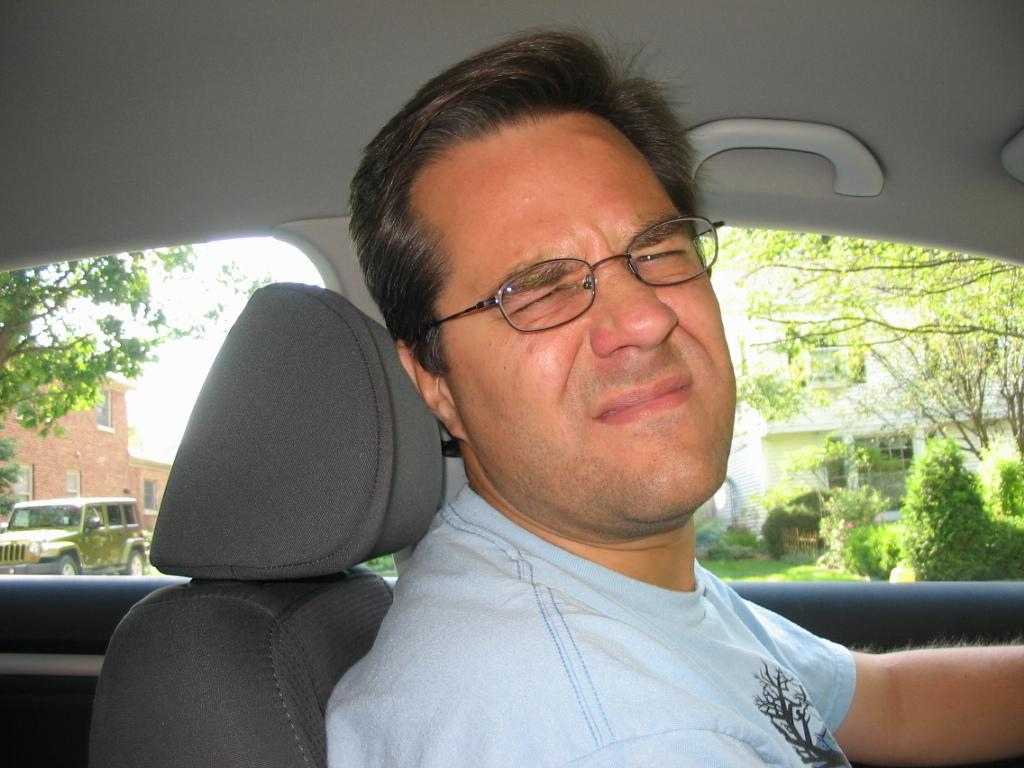What is the main subject of the image? The main subject of the image is a man. What is the man doing in the image? The man is sitting in a car and posing to the camera. How does the man appear to be feeling in the image? The man has an irritating expression in the image. What type of son can be heard singing in the image? There is no son present in the image, and therefore no such activity can be observed. What type of line is visible connecting the man to the car in the image? There is no line connecting the man to the car in the image. What type of plane is visible flying in the sky in the image? There is no plane visible in the sky in the image. 